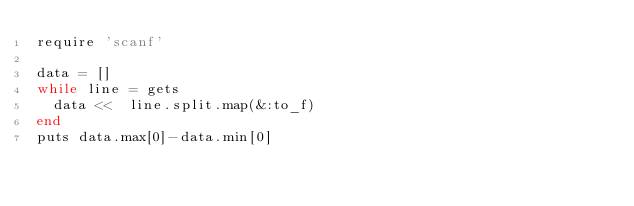Convert code to text. <code><loc_0><loc_0><loc_500><loc_500><_Ruby_>require 'scanf'

data = []
while line = gets
  data <<  line.split.map(&:to_f)
end
puts data.max[0]-data.min[0]</code> 